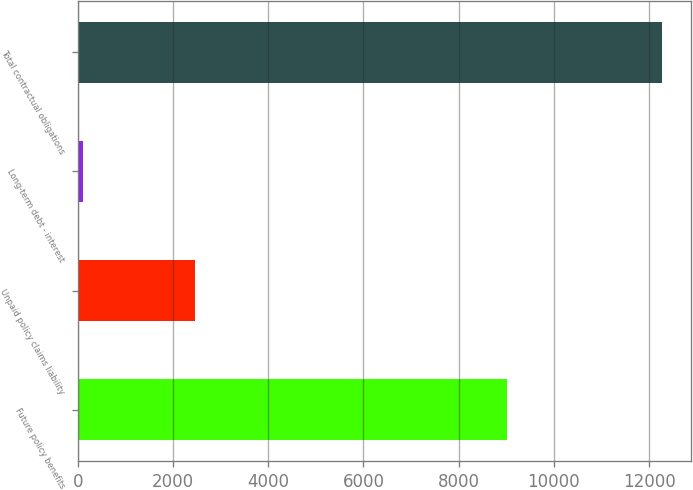<chart> <loc_0><loc_0><loc_500><loc_500><bar_chart><fcel>Future policy benefits<fcel>Unpaid policy claims liability<fcel>Long-term debt - interest<fcel>Total contractual obligations<nl><fcel>9018<fcel>2463<fcel>119<fcel>12268<nl></chart> 